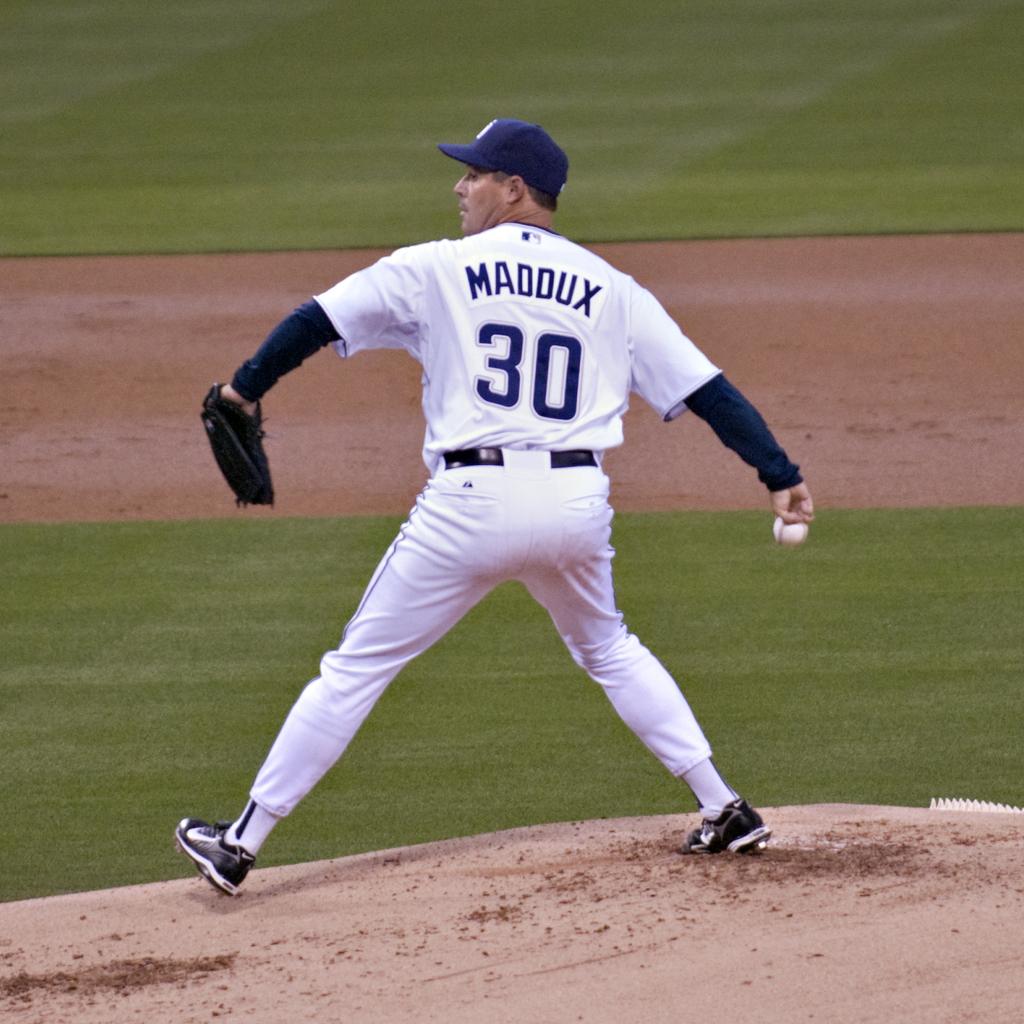What number is the pitcher?
Keep it short and to the point. 30. What does his jersey say?
Give a very brief answer. Maddux. 